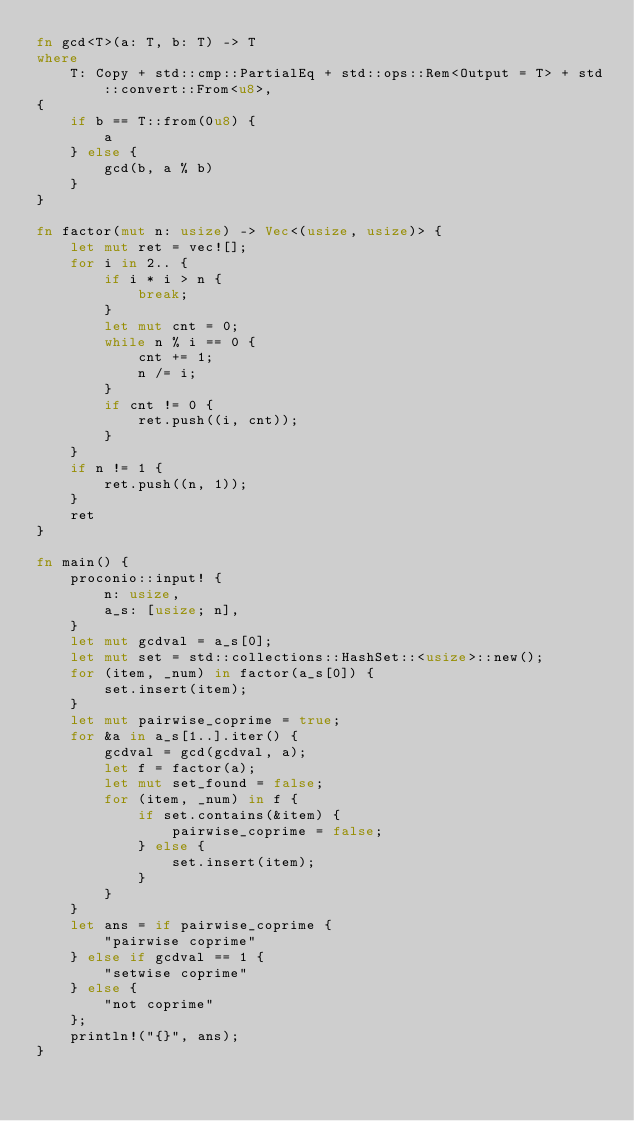<code> <loc_0><loc_0><loc_500><loc_500><_Rust_>fn gcd<T>(a: T, b: T) -> T
where
    T: Copy + std::cmp::PartialEq + std::ops::Rem<Output = T> + std::convert::From<u8>,
{
    if b == T::from(0u8) {
        a
    } else {
        gcd(b, a % b)
    }
}

fn factor(mut n: usize) -> Vec<(usize, usize)> {
    let mut ret = vec![];
    for i in 2.. {
        if i * i > n {
            break;
        }
        let mut cnt = 0;
        while n % i == 0 {
            cnt += 1;
            n /= i;
        }
        if cnt != 0 {
            ret.push((i, cnt));
        }
    }
    if n != 1 {
        ret.push((n, 1));
    }
    ret
}

fn main() {
    proconio::input! {
        n: usize,
        a_s: [usize; n],
    }
    let mut gcdval = a_s[0];
    let mut set = std::collections::HashSet::<usize>::new();
    for (item, _num) in factor(a_s[0]) {
        set.insert(item);
    }
    let mut pairwise_coprime = true;
    for &a in a_s[1..].iter() {
        gcdval = gcd(gcdval, a);
        let f = factor(a);
        let mut set_found = false;
        for (item, _num) in f {
            if set.contains(&item) {
                pairwise_coprime = false;
            } else {
                set.insert(item);
            }
        }
    }
    let ans = if pairwise_coprime {
        "pairwise coprime"
    } else if gcdval == 1 {
        "setwise coprime"
    } else {
        "not coprime"
    };
    println!("{}", ans);
}
</code> 